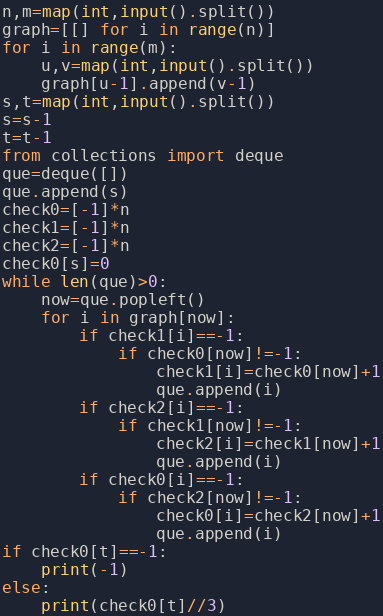<code> <loc_0><loc_0><loc_500><loc_500><_Python_>n,m=map(int,input().split())
graph=[[] for i in range(n)]
for i in range(m):
    u,v=map(int,input().split())
    graph[u-1].append(v-1)
s,t=map(int,input().split())
s=s-1
t=t-1
from collections import deque
que=deque([])
que.append(s)
check0=[-1]*n
check1=[-1]*n
check2=[-1]*n
check0[s]=0
while len(que)>0:
    now=que.popleft()
    for i in graph[now]:
        if check1[i]==-1:
            if check0[now]!=-1:
                check1[i]=check0[now]+1
                que.append(i)
        if check2[i]==-1:
            if check1[now]!=-1:
                check2[i]=check1[now]+1
                que.append(i)
        if check0[i]==-1:
            if check2[now]!=-1:
                check0[i]=check2[now]+1
                que.append(i)
if check0[t]==-1:
    print(-1)
else:
    print(check0[t]//3)
</code> 